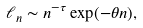<formula> <loc_0><loc_0><loc_500><loc_500>\ell _ { n } \sim n ^ { - \tau } \exp ( - \theta n ) ,</formula> 